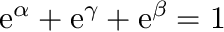<formula> <loc_0><loc_0><loc_500><loc_500>e ^ { \alpha } + e ^ { \gamma } + e ^ { \beta } = 1</formula> 